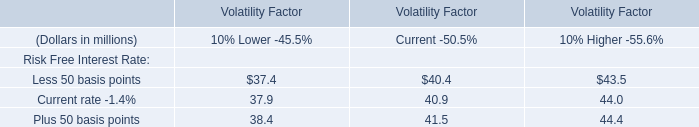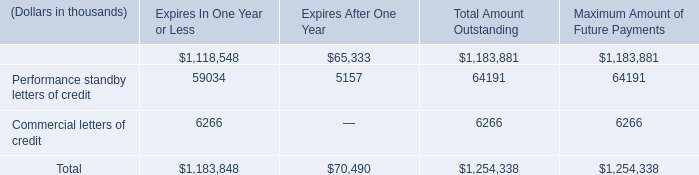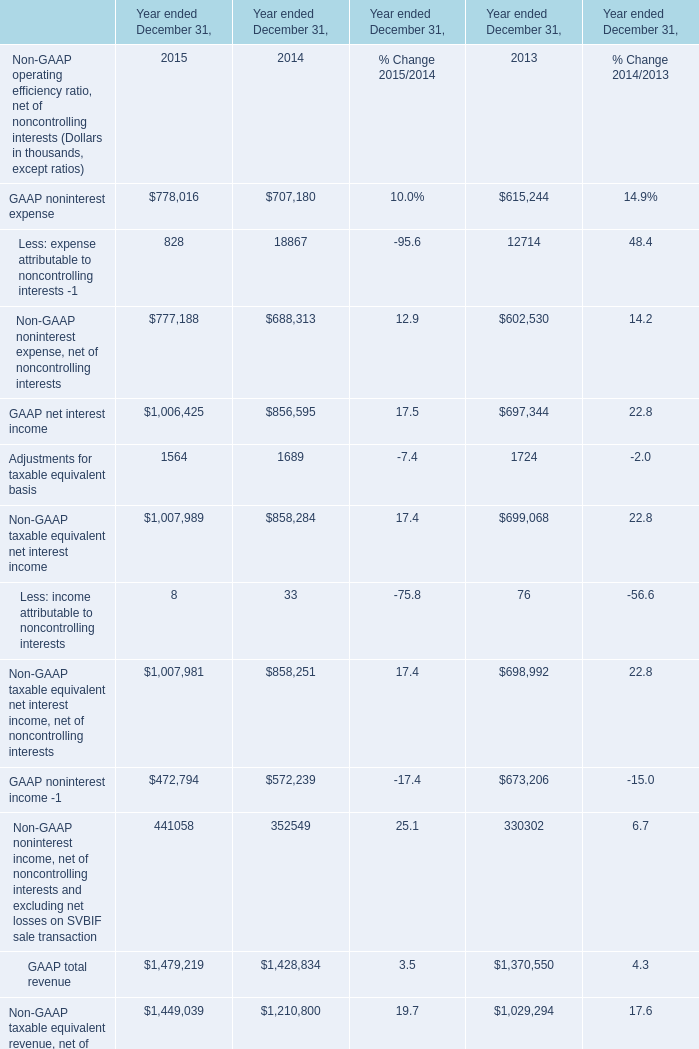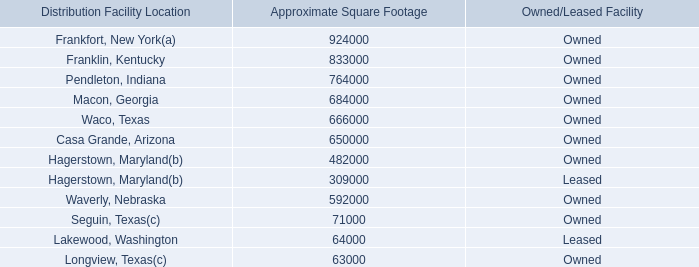The total amount of which section ranks first in 2015? 
Answer: GAAP total revenue. 